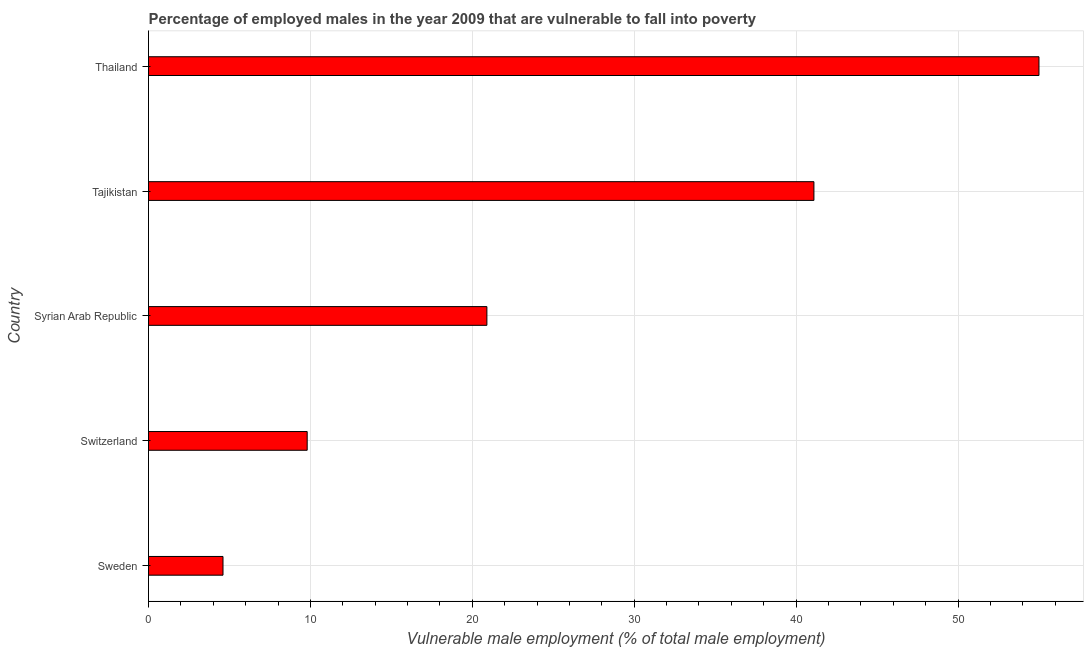What is the title of the graph?
Provide a succinct answer. Percentage of employed males in the year 2009 that are vulnerable to fall into poverty. What is the label or title of the X-axis?
Offer a terse response. Vulnerable male employment (% of total male employment). What is the label or title of the Y-axis?
Provide a short and direct response. Country. What is the percentage of employed males who are vulnerable to fall into poverty in Tajikistan?
Your answer should be very brief. 41.1. Across all countries, what is the minimum percentage of employed males who are vulnerable to fall into poverty?
Make the answer very short. 4.6. In which country was the percentage of employed males who are vulnerable to fall into poverty maximum?
Make the answer very short. Thailand. What is the sum of the percentage of employed males who are vulnerable to fall into poverty?
Ensure brevity in your answer.  131.4. What is the average percentage of employed males who are vulnerable to fall into poverty per country?
Keep it short and to the point. 26.28. What is the median percentage of employed males who are vulnerable to fall into poverty?
Offer a very short reply. 20.9. In how many countries, is the percentage of employed males who are vulnerable to fall into poverty greater than 44 %?
Ensure brevity in your answer.  1. What is the ratio of the percentage of employed males who are vulnerable to fall into poverty in Tajikistan to that in Thailand?
Keep it short and to the point. 0.75. Is the difference between the percentage of employed males who are vulnerable to fall into poverty in Sweden and Thailand greater than the difference between any two countries?
Keep it short and to the point. Yes. Is the sum of the percentage of employed males who are vulnerable to fall into poverty in Switzerland and Tajikistan greater than the maximum percentage of employed males who are vulnerable to fall into poverty across all countries?
Give a very brief answer. No. What is the difference between the highest and the lowest percentage of employed males who are vulnerable to fall into poverty?
Make the answer very short. 50.4. How many bars are there?
Offer a terse response. 5. Are all the bars in the graph horizontal?
Make the answer very short. Yes. Are the values on the major ticks of X-axis written in scientific E-notation?
Offer a terse response. No. What is the Vulnerable male employment (% of total male employment) in Sweden?
Your answer should be very brief. 4.6. What is the Vulnerable male employment (% of total male employment) in Switzerland?
Make the answer very short. 9.8. What is the Vulnerable male employment (% of total male employment) of Syrian Arab Republic?
Keep it short and to the point. 20.9. What is the Vulnerable male employment (% of total male employment) in Tajikistan?
Make the answer very short. 41.1. What is the difference between the Vulnerable male employment (% of total male employment) in Sweden and Syrian Arab Republic?
Provide a succinct answer. -16.3. What is the difference between the Vulnerable male employment (% of total male employment) in Sweden and Tajikistan?
Provide a short and direct response. -36.5. What is the difference between the Vulnerable male employment (% of total male employment) in Sweden and Thailand?
Offer a very short reply. -50.4. What is the difference between the Vulnerable male employment (% of total male employment) in Switzerland and Syrian Arab Republic?
Your answer should be compact. -11.1. What is the difference between the Vulnerable male employment (% of total male employment) in Switzerland and Tajikistan?
Offer a terse response. -31.3. What is the difference between the Vulnerable male employment (% of total male employment) in Switzerland and Thailand?
Your answer should be compact. -45.2. What is the difference between the Vulnerable male employment (% of total male employment) in Syrian Arab Republic and Tajikistan?
Keep it short and to the point. -20.2. What is the difference between the Vulnerable male employment (% of total male employment) in Syrian Arab Republic and Thailand?
Your answer should be compact. -34.1. What is the ratio of the Vulnerable male employment (% of total male employment) in Sweden to that in Switzerland?
Give a very brief answer. 0.47. What is the ratio of the Vulnerable male employment (% of total male employment) in Sweden to that in Syrian Arab Republic?
Provide a succinct answer. 0.22. What is the ratio of the Vulnerable male employment (% of total male employment) in Sweden to that in Tajikistan?
Offer a very short reply. 0.11. What is the ratio of the Vulnerable male employment (% of total male employment) in Sweden to that in Thailand?
Your answer should be very brief. 0.08. What is the ratio of the Vulnerable male employment (% of total male employment) in Switzerland to that in Syrian Arab Republic?
Make the answer very short. 0.47. What is the ratio of the Vulnerable male employment (% of total male employment) in Switzerland to that in Tajikistan?
Give a very brief answer. 0.24. What is the ratio of the Vulnerable male employment (% of total male employment) in Switzerland to that in Thailand?
Your response must be concise. 0.18. What is the ratio of the Vulnerable male employment (% of total male employment) in Syrian Arab Republic to that in Tajikistan?
Give a very brief answer. 0.51. What is the ratio of the Vulnerable male employment (% of total male employment) in Syrian Arab Republic to that in Thailand?
Ensure brevity in your answer.  0.38. What is the ratio of the Vulnerable male employment (% of total male employment) in Tajikistan to that in Thailand?
Make the answer very short. 0.75. 